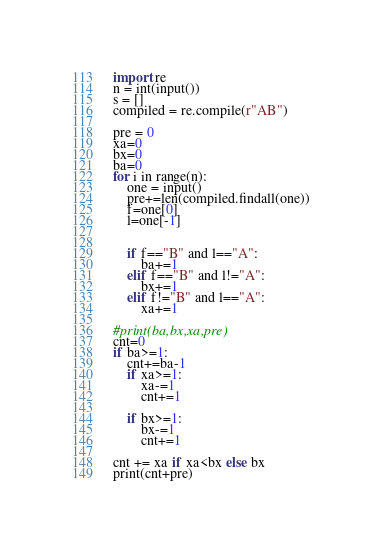<code> <loc_0><loc_0><loc_500><loc_500><_Python_>import re
n = int(input())
s = []
compiled = re.compile(r"AB")

pre = 0
xa=0
bx=0
ba=0
for i in range(n):
    one = input()
    pre+=len(compiled.findall(one))
    f=one[0]
    l=one[-1]


    if f=="B" and l=="A":
        ba+=1
    elif f=="B" and l!="A":
        bx+=1
    elif f!="B" and l=="A":
        xa+=1

#print(ba,bx,xa,pre)
cnt=0
if ba>=1:
    cnt+=ba-1
    if xa>=1:
        xa-=1
        cnt+=1
    
    if bx>=1:
        bx-=1
        cnt+=1

cnt += xa if xa<bx else bx
print(cnt+pre)

</code> 